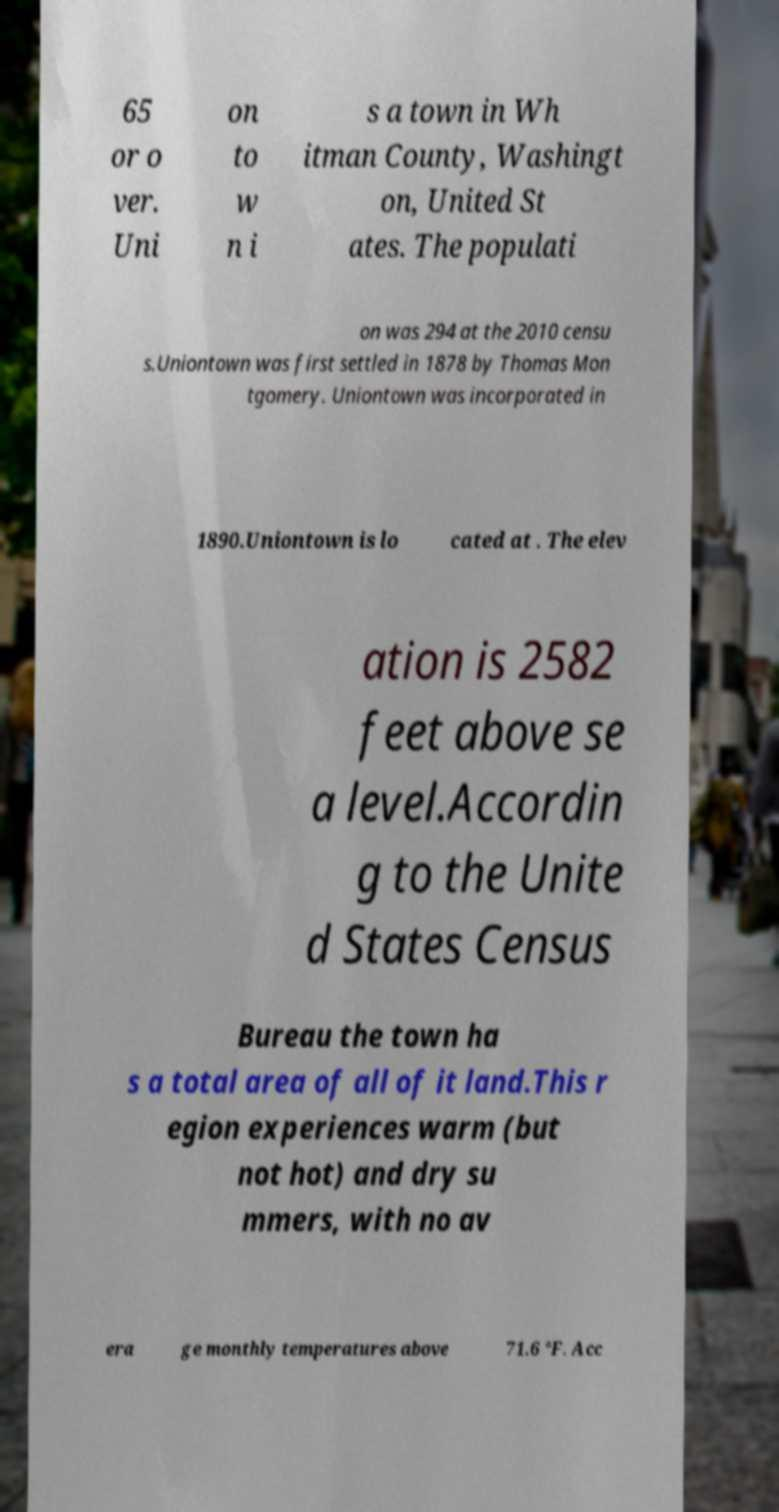Can you read and provide the text displayed in the image?This photo seems to have some interesting text. Can you extract and type it out for me? 65 or o ver. Uni on to w n i s a town in Wh itman County, Washingt on, United St ates. The populati on was 294 at the 2010 censu s.Uniontown was first settled in 1878 by Thomas Mon tgomery. Uniontown was incorporated in 1890.Uniontown is lo cated at . The elev ation is 2582 feet above se a level.Accordin g to the Unite d States Census Bureau the town ha s a total area of all of it land.This r egion experiences warm (but not hot) and dry su mmers, with no av era ge monthly temperatures above 71.6 °F. Acc 